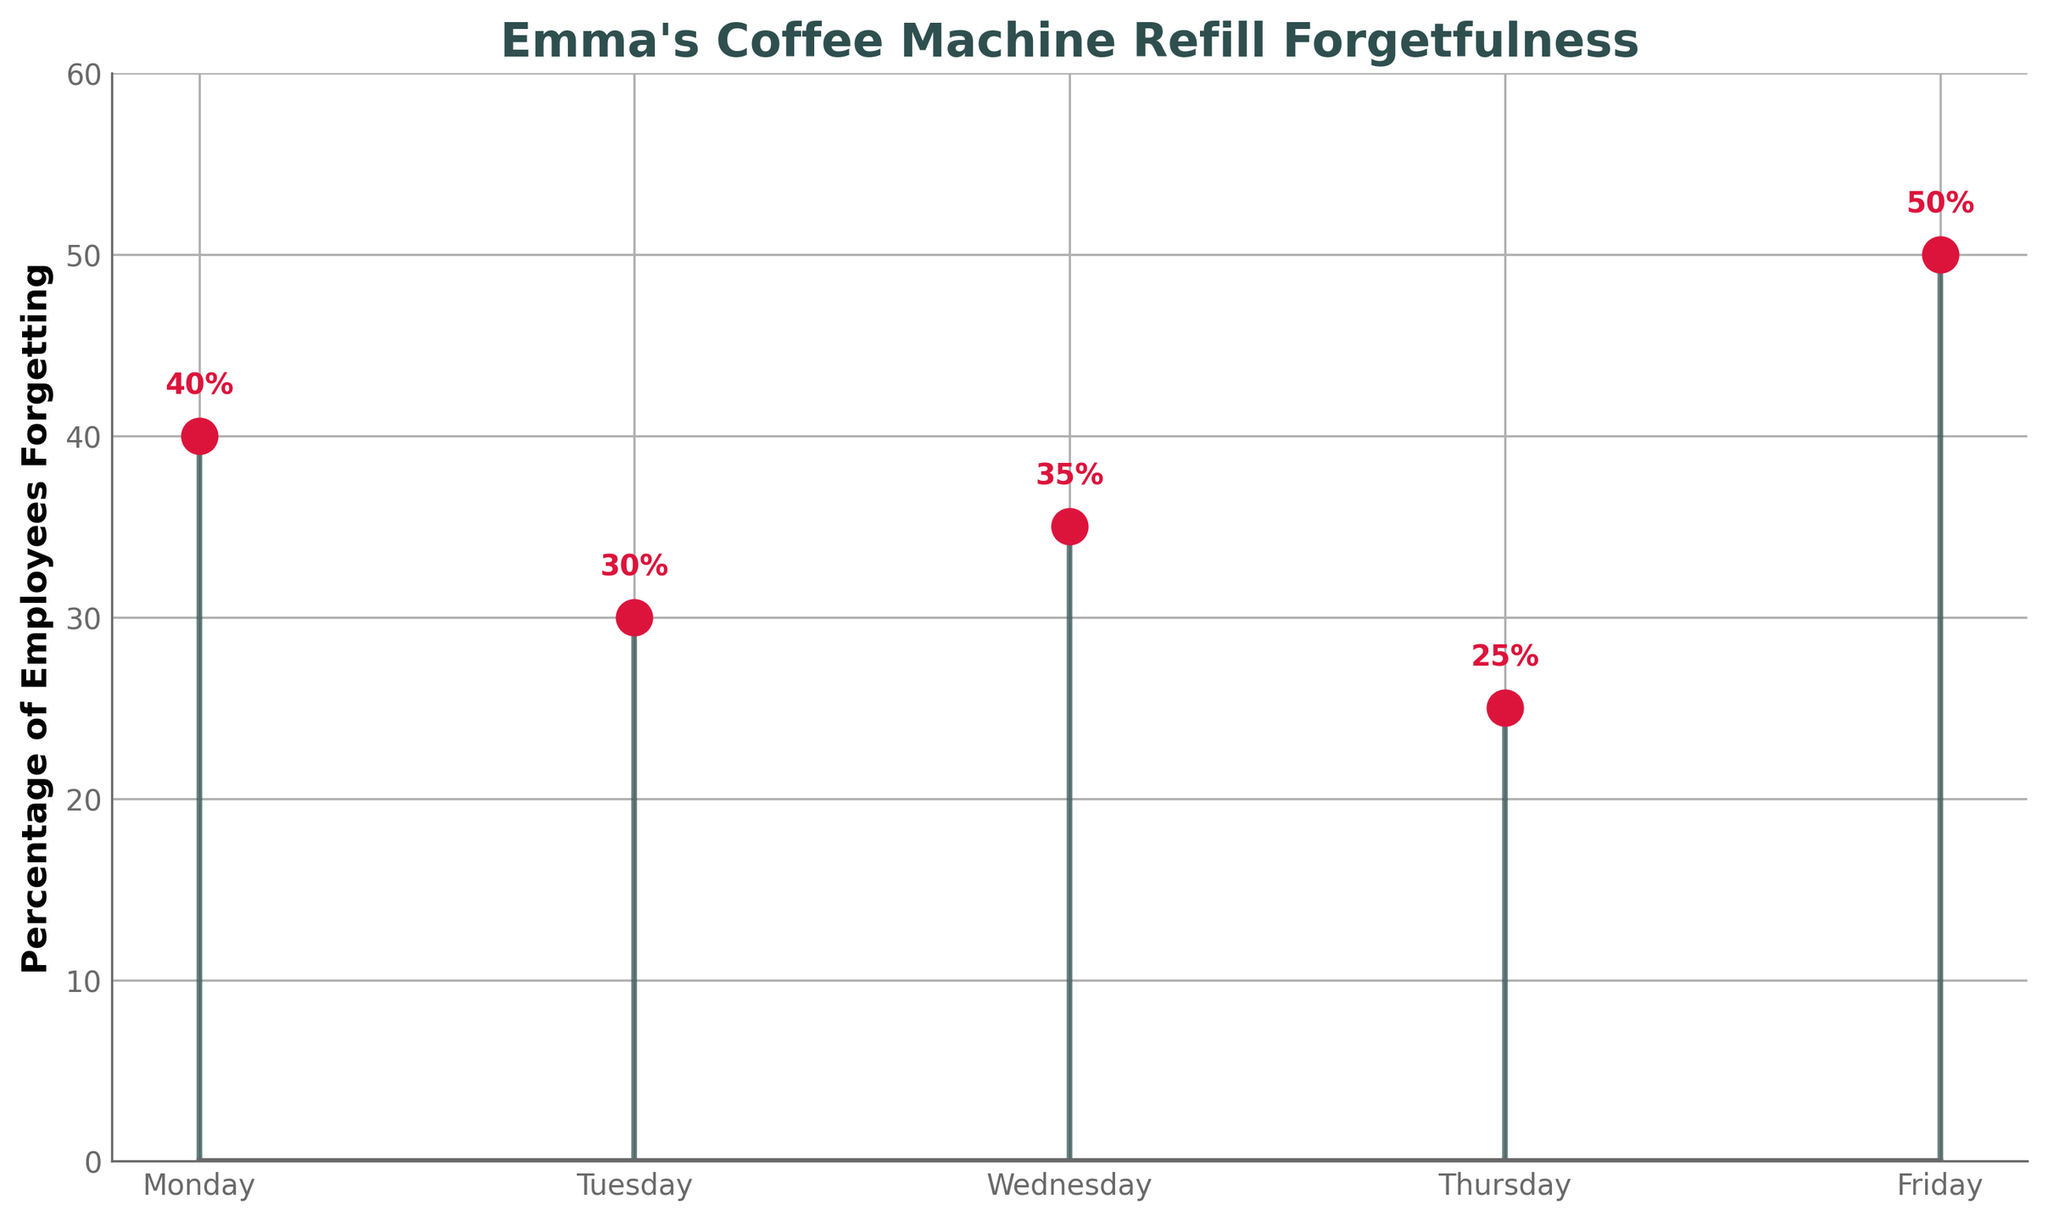What is the title of the figure? The figure's title is displayed at the top, providing context for the data.
Answer: Emma's Coffee Machine Refill Forgetfulness Which day has the highest percentage of employees forgetting to refill the coffee machine? By looking at the heights of the stems, the highest percentage is on the day with the tallest stem.
Answer: Friday What is the percentage of employees forgetting to refill the coffee machine on Wednesday? Find the stem corresponding to Wednesday and read the percentage label above it.
Answer: 35% Do more employees forget to refill the coffee machine on Monday or Tuesday? Compare the heights of the stems for Monday and Tuesday; the taller stem indicates a higher percentage.
Answer: Monday By how much does the percentage on Friday exceed the percentage on Thursday? Subtract the percentage on Thursday from the percentage on Friday. The percentages are directly labeled above the stems.
Answer: 25% What is the average percentage of employees forgetting to refill the coffee machine from Monday to Friday? Sum the percentages for all days and divide by the number of days: (40 + 30 + 35 + 25 + 50) / 5.
Answer: 36% What is the total percentage of employees forgetting to refill the coffee machine on Monday and Friday combined? Add the percentages for Monday and Friday: 40 + 50.
Answer: 90% Which day has the lowest percentage of employees forgetting to refill the coffee machine? Look for the shortest stem; the day it corresponds to has the lowest percentage.
Answer: Thursday Is the percentage of employees forgetting to refill the coffee machine on Tuesday less than the percentage on Wednesday? Compare the labeled percentages for Tuesday and Wednesday.
Answer: Yes 